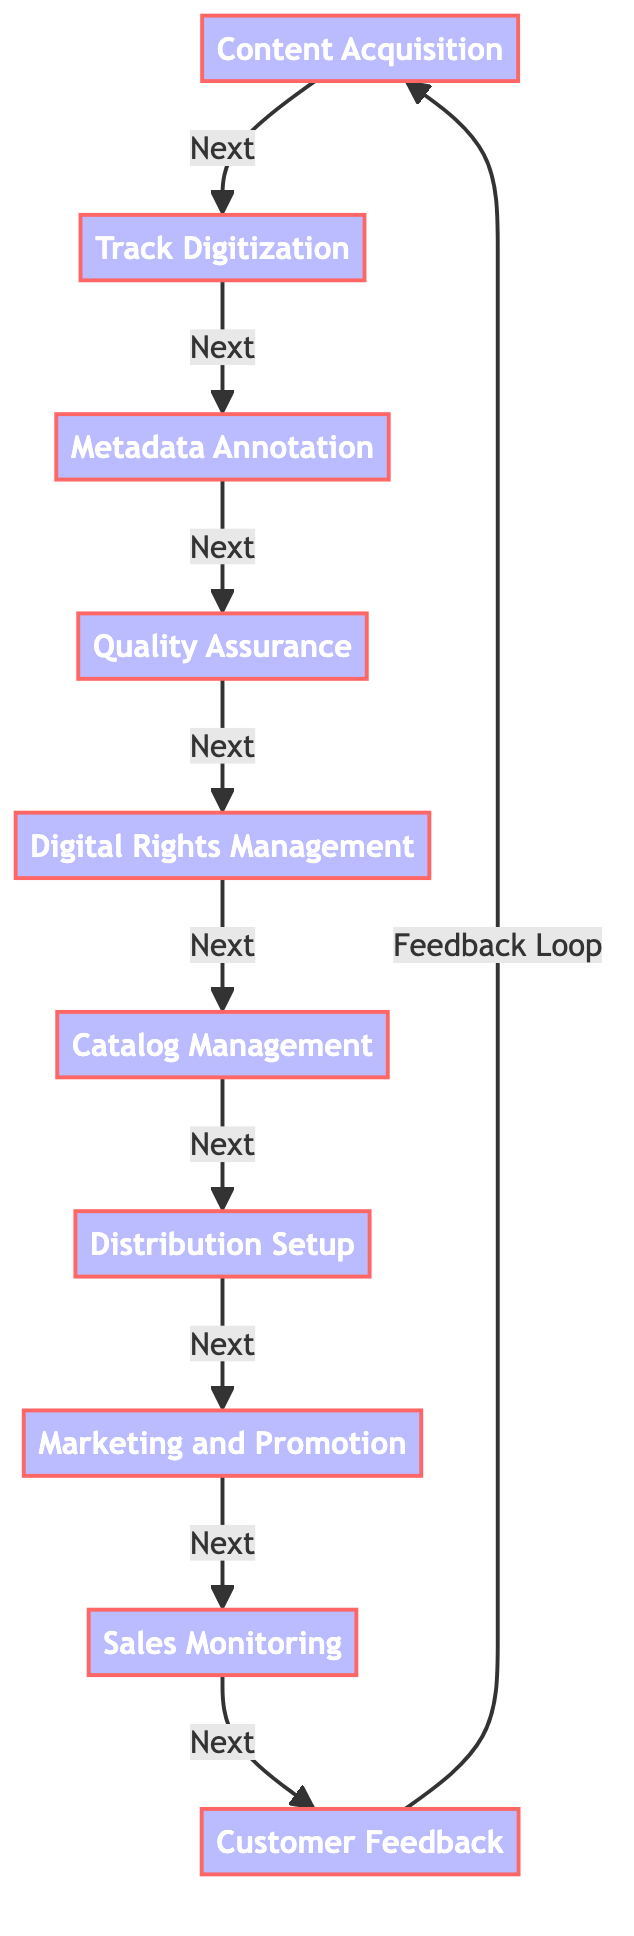What is the first step in the digital music distribution process? The first step listed in the flowchart is "Content Acquisition". It is identified as the starting point before moving to the next step.
Answer: Content Acquisition How many total steps are there in the digital music distribution process? There are ten distinct steps identified in the diagram, each connecting to the next in a sequential flow.
Answer: 10 What follows "Quality Assurance" in the sequence? The process immediately after "Quality Assurance" is "Digital Rights Management", as indicated by the arrow leading to the next step.
Answer: Digital Rights Management Which step involves organizing music tracks into a catalog? The step that deals with organizing digital music tracks is "Catalog Management", where tracks are made accessible and searchable.
Answer: Catalog Management What is the last step in the digital music distribution process before the feedback loop? The last step before the feedback loop returns to "Content Acquisition" is "Customer Feedback" which involves analyzing user responses.
Answer: Customer Feedback What are the first three steps in the process? The first three steps, following the flow, are "Content Acquisition", "Track Digitization", and "Metadata Annotation". These are consecutive steps that form the initial part of the process.
Answer: Content Acquisition, Track Digitization, Metadata Annotation In which step are marketing strategies executed? "Marketing and Promotion" is the step where strategies to promote reggae and gospel music tracks are developed and executed.
Answer: Marketing and Promotion What is the purpose of Digital Rights Management? The purpose of "Digital Rights Management" is to apply protections to ensure the digital tracks are not used or distributed without authorization.
Answer: Prevent unauthorized use What connection leads from "Sales Monitoring"? "Sales Monitoring" leads directly to "Customer Feedback", showing the progression from tracking sales to gathering user insights.
Answer: Customer Feedback What type of feedback is collected in the last step? The last step collects "Customer Feedback", which involves analyzing responses and insights from users about their experiences.
Answer: Customer Feedback 